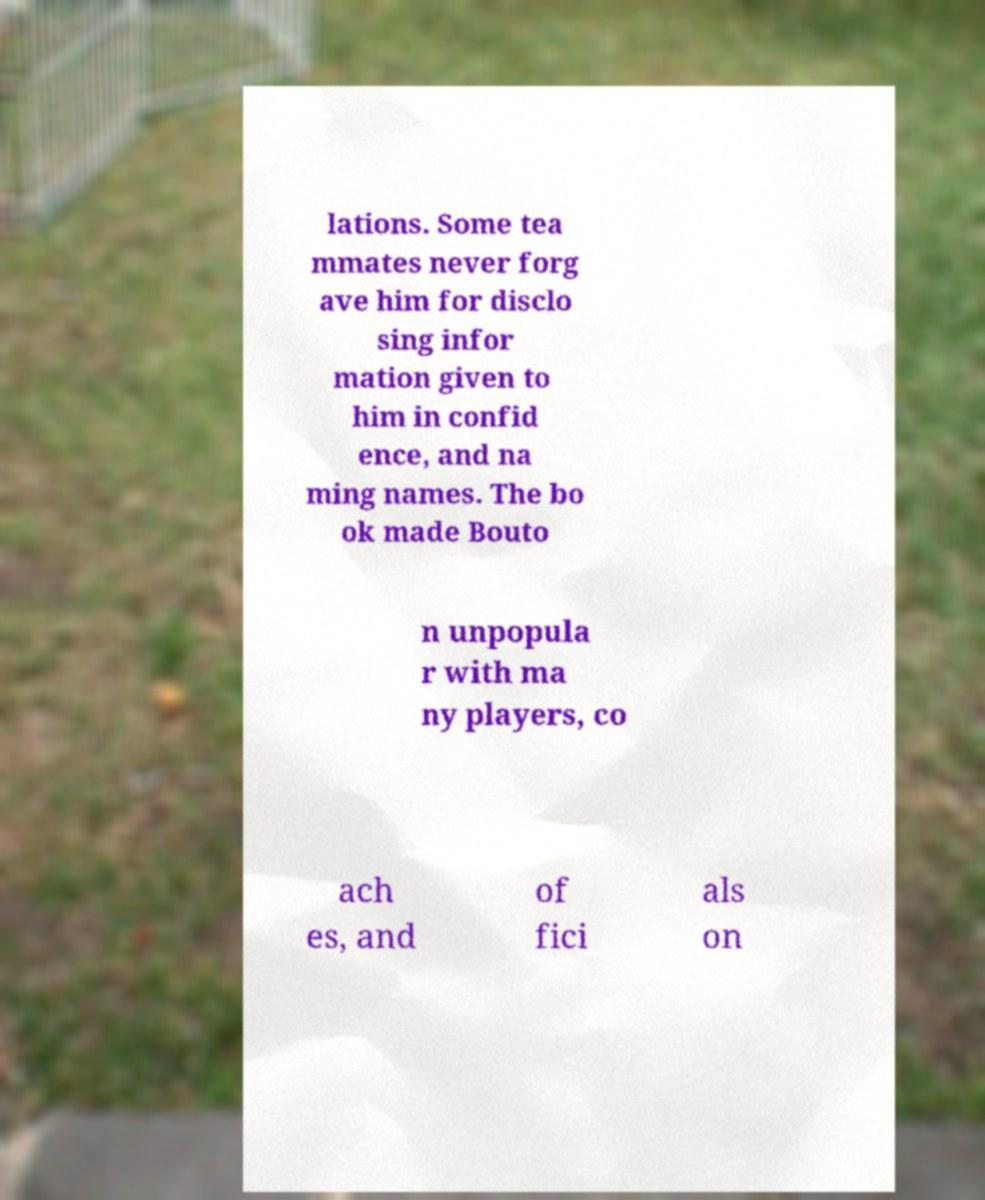What messages or text are displayed in this image? I need them in a readable, typed format. lations. Some tea mmates never forg ave him for disclo sing infor mation given to him in confid ence, and na ming names. The bo ok made Bouto n unpopula r with ma ny players, co ach es, and of fici als on 